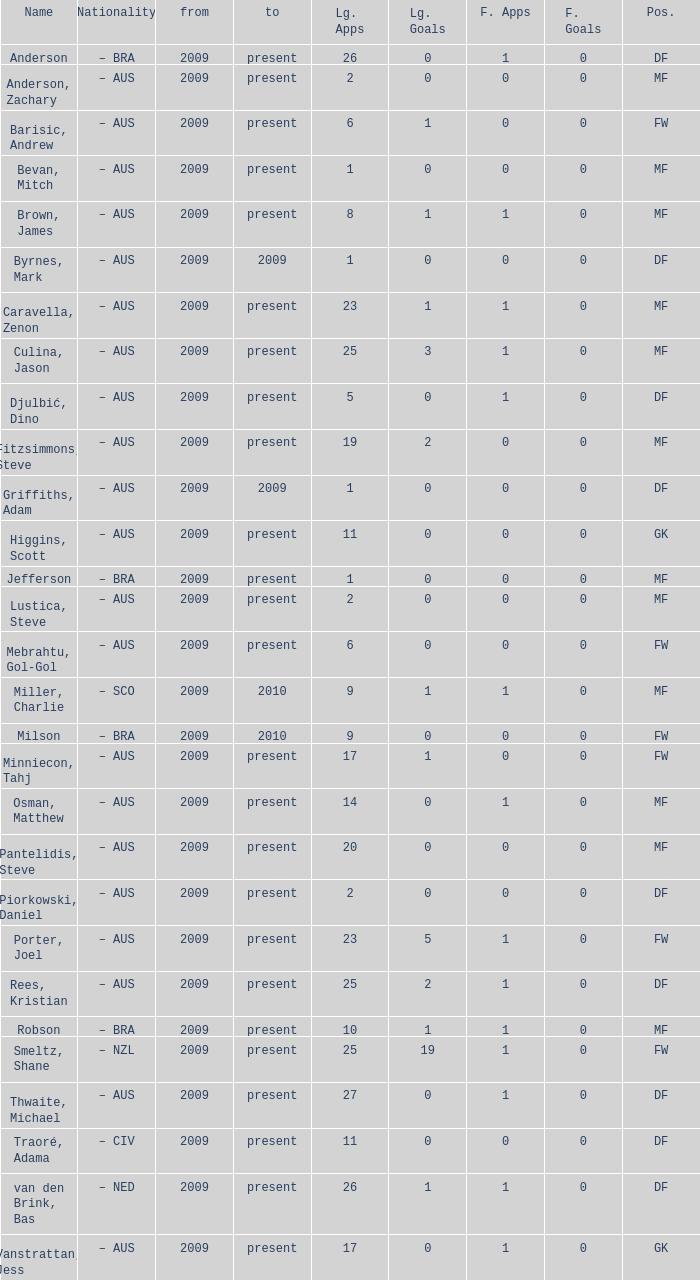Name the mosst finals apps 1.0. 